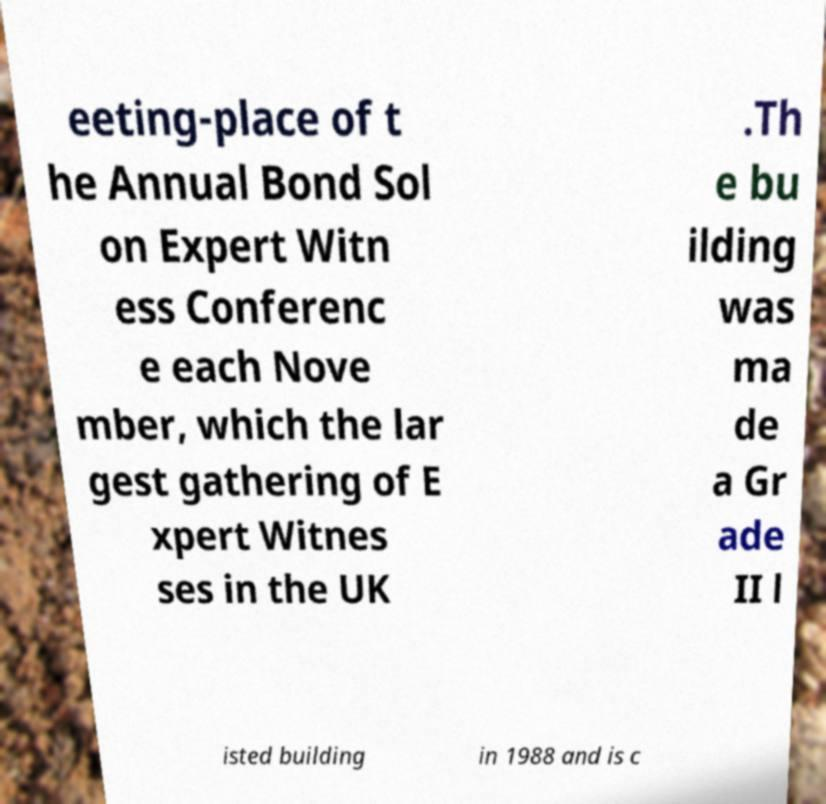Can you accurately transcribe the text from the provided image for me? eeting-place of t he Annual Bond Sol on Expert Witn ess Conferenc e each Nove mber, which the lar gest gathering of E xpert Witnes ses in the UK .Th e bu ilding was ma de a Gr ade II l isted building in 1988 and is c 